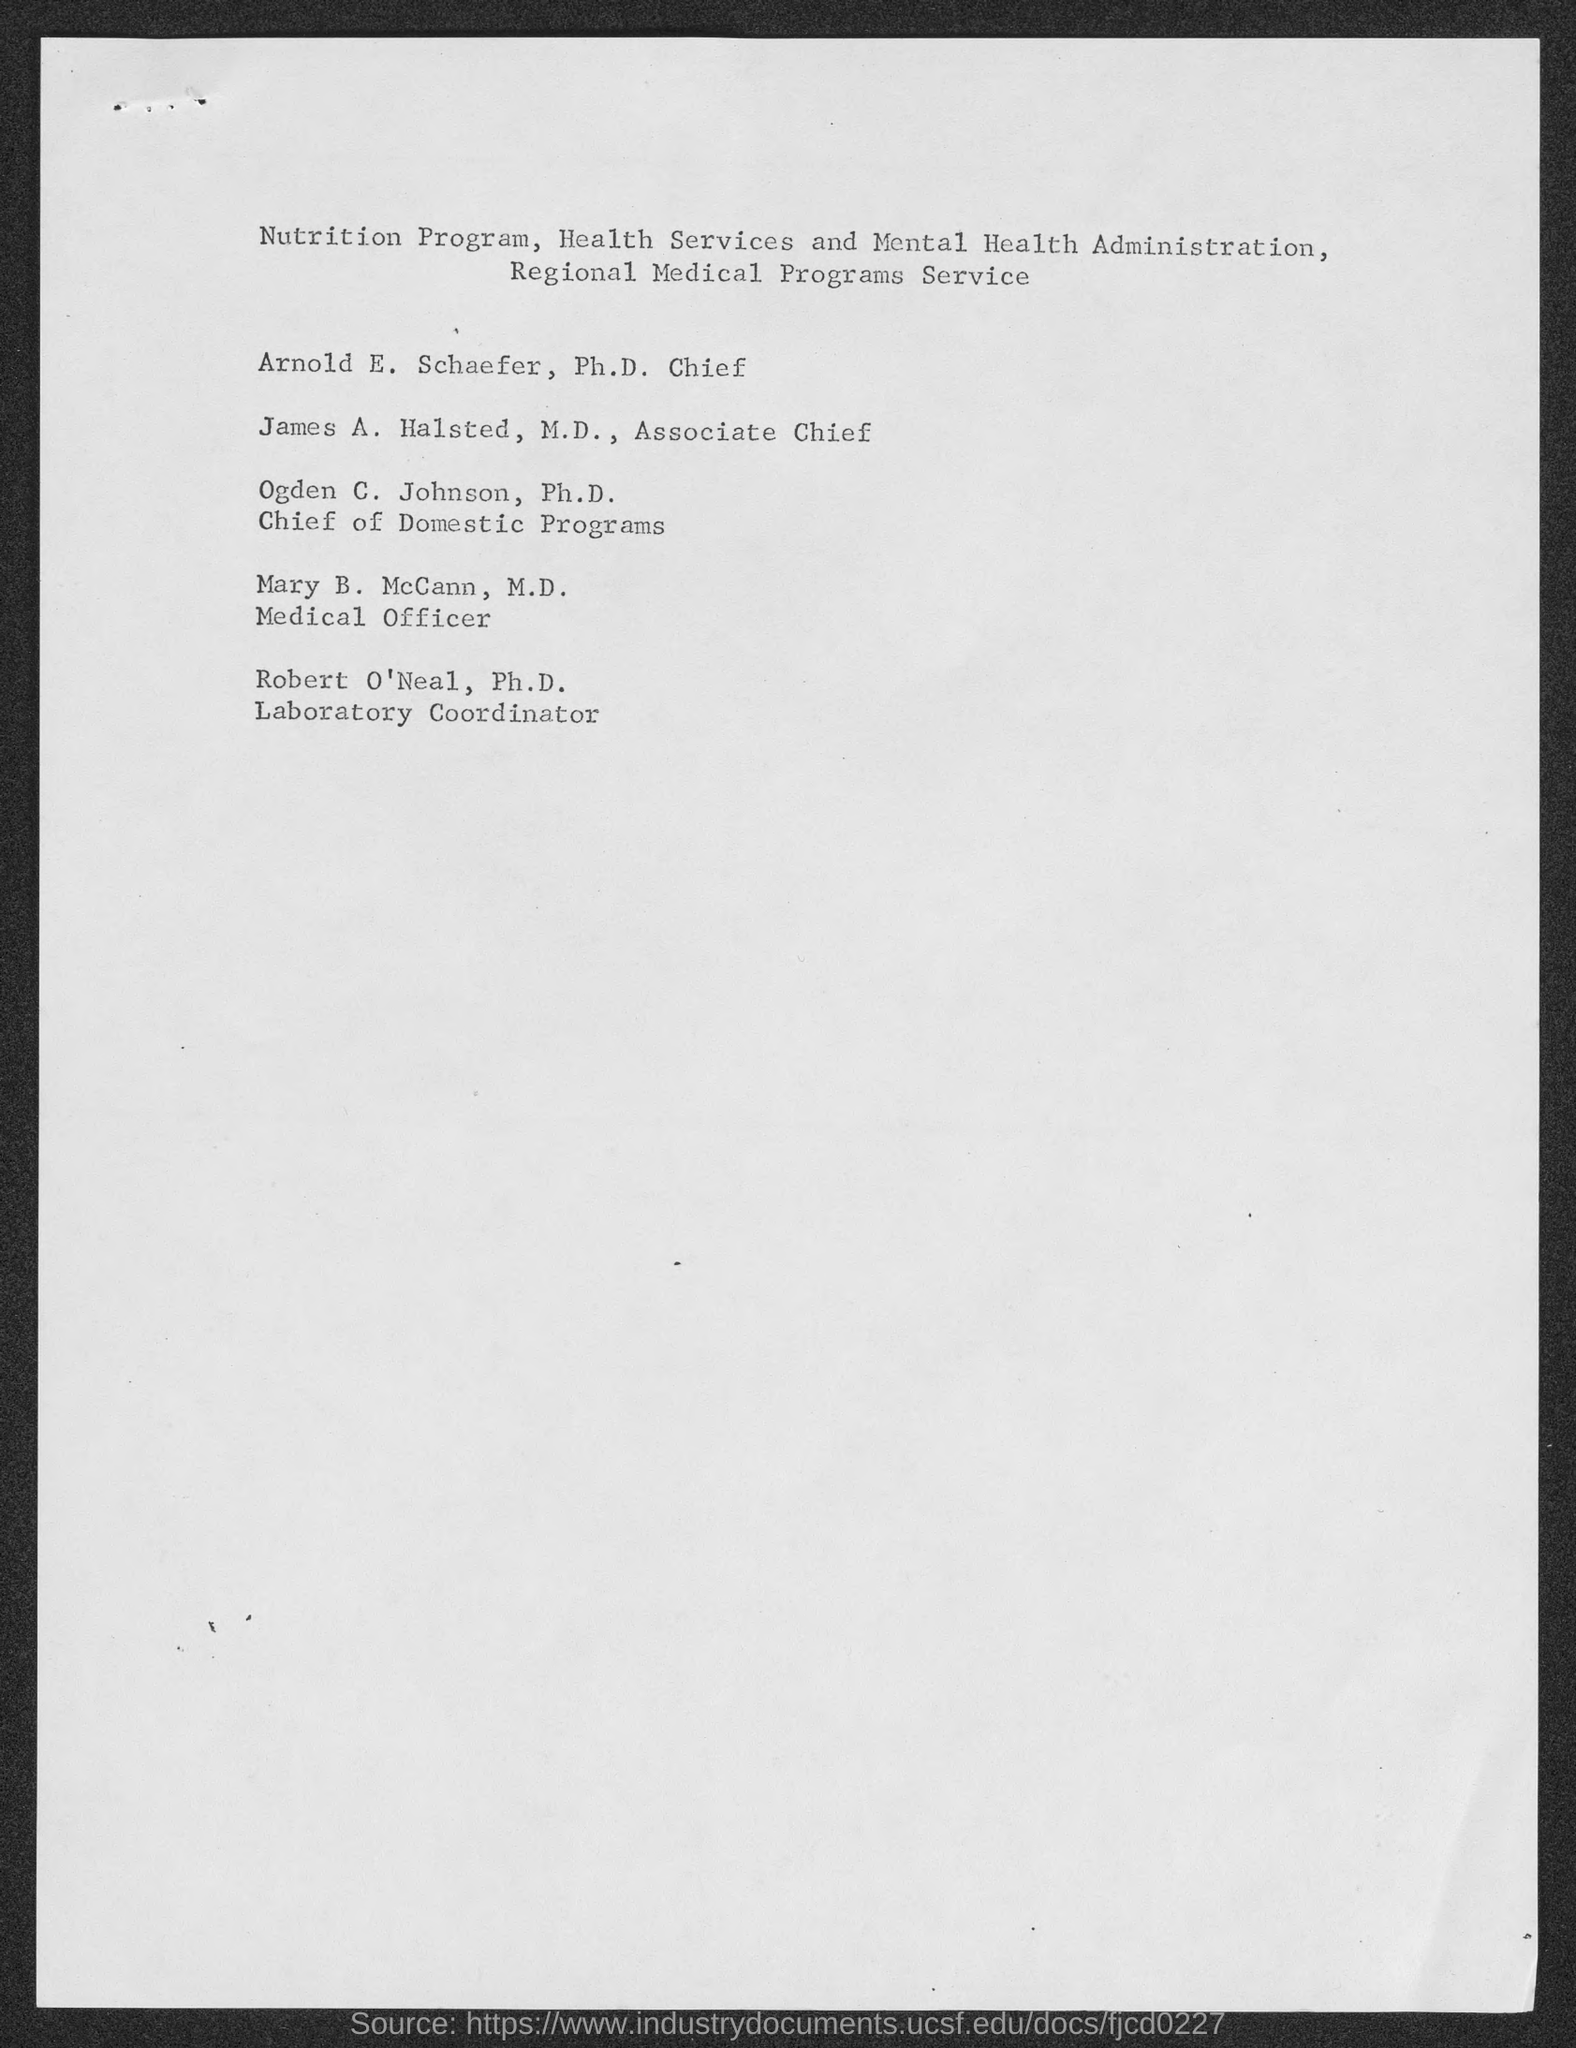Outline some significant characteristics in this image. The Laboratory Coordinator is Robert O'Neal, Ph.D. James A. Halsted, M.D. is the Associate Chief Medical Officer. Ogden C. Johnson, Ph.D., is the Chief of Domestic Programs. The Ph.D. Chief is Arnold E. Schaefer. 